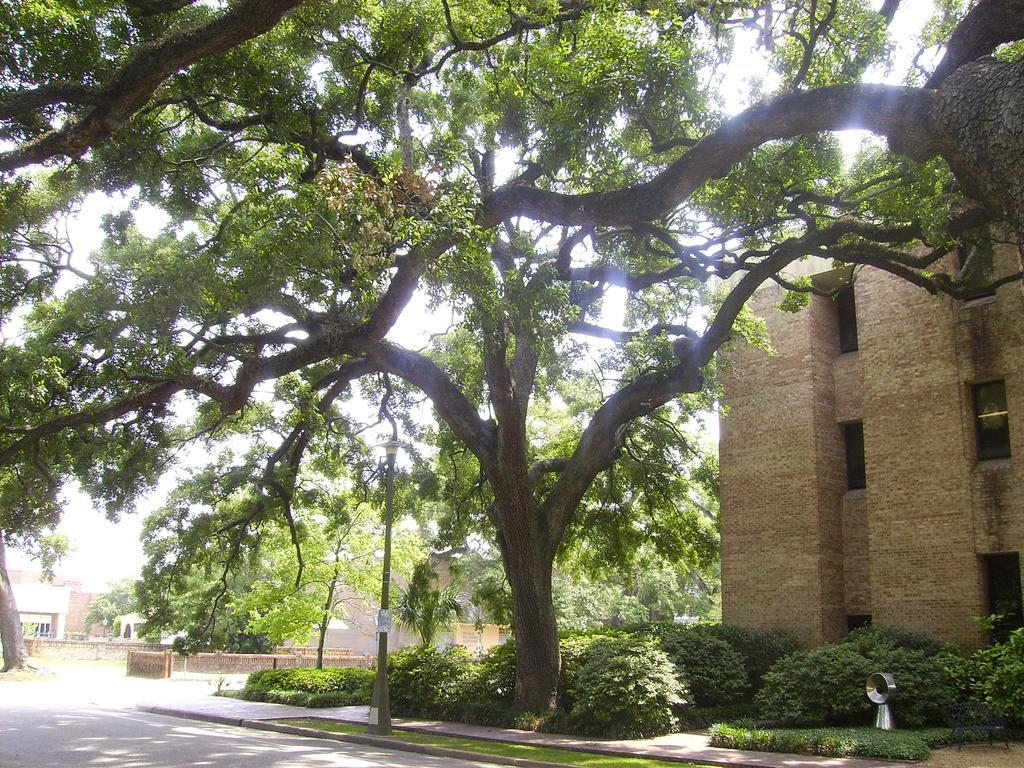What type of natural elements can be seen in the image? There are trees and plants in the image. What type of man-made structures are present in the image? There are buildings in the image. What type of vertical structures can be seen in the image? There are poles in the image. What type of dinner is being served in the image? There is no dinner present in the image; it features trees, plants, buildings, and poles. What type of blade can be seen cutting through the trees in the image? There is no blade present in the image; it only features trees, plants, buildings, and poles. 